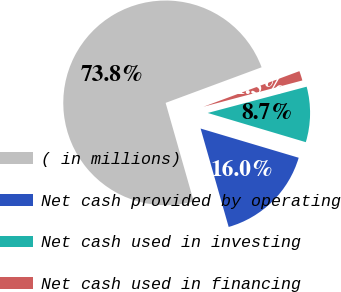Convert chart. <chart><loc_0><loc_0><loc_500><loc_500><pie_chart><fcel>( in millions)<fcel>Net cash provided by operating<fcel>Net cash used in investing<fcel>Net cash used in financing<nl><fcel>73.77%<fcel>15.97%<fcel>8.74%<fcel>1.52%<nl></chart> 